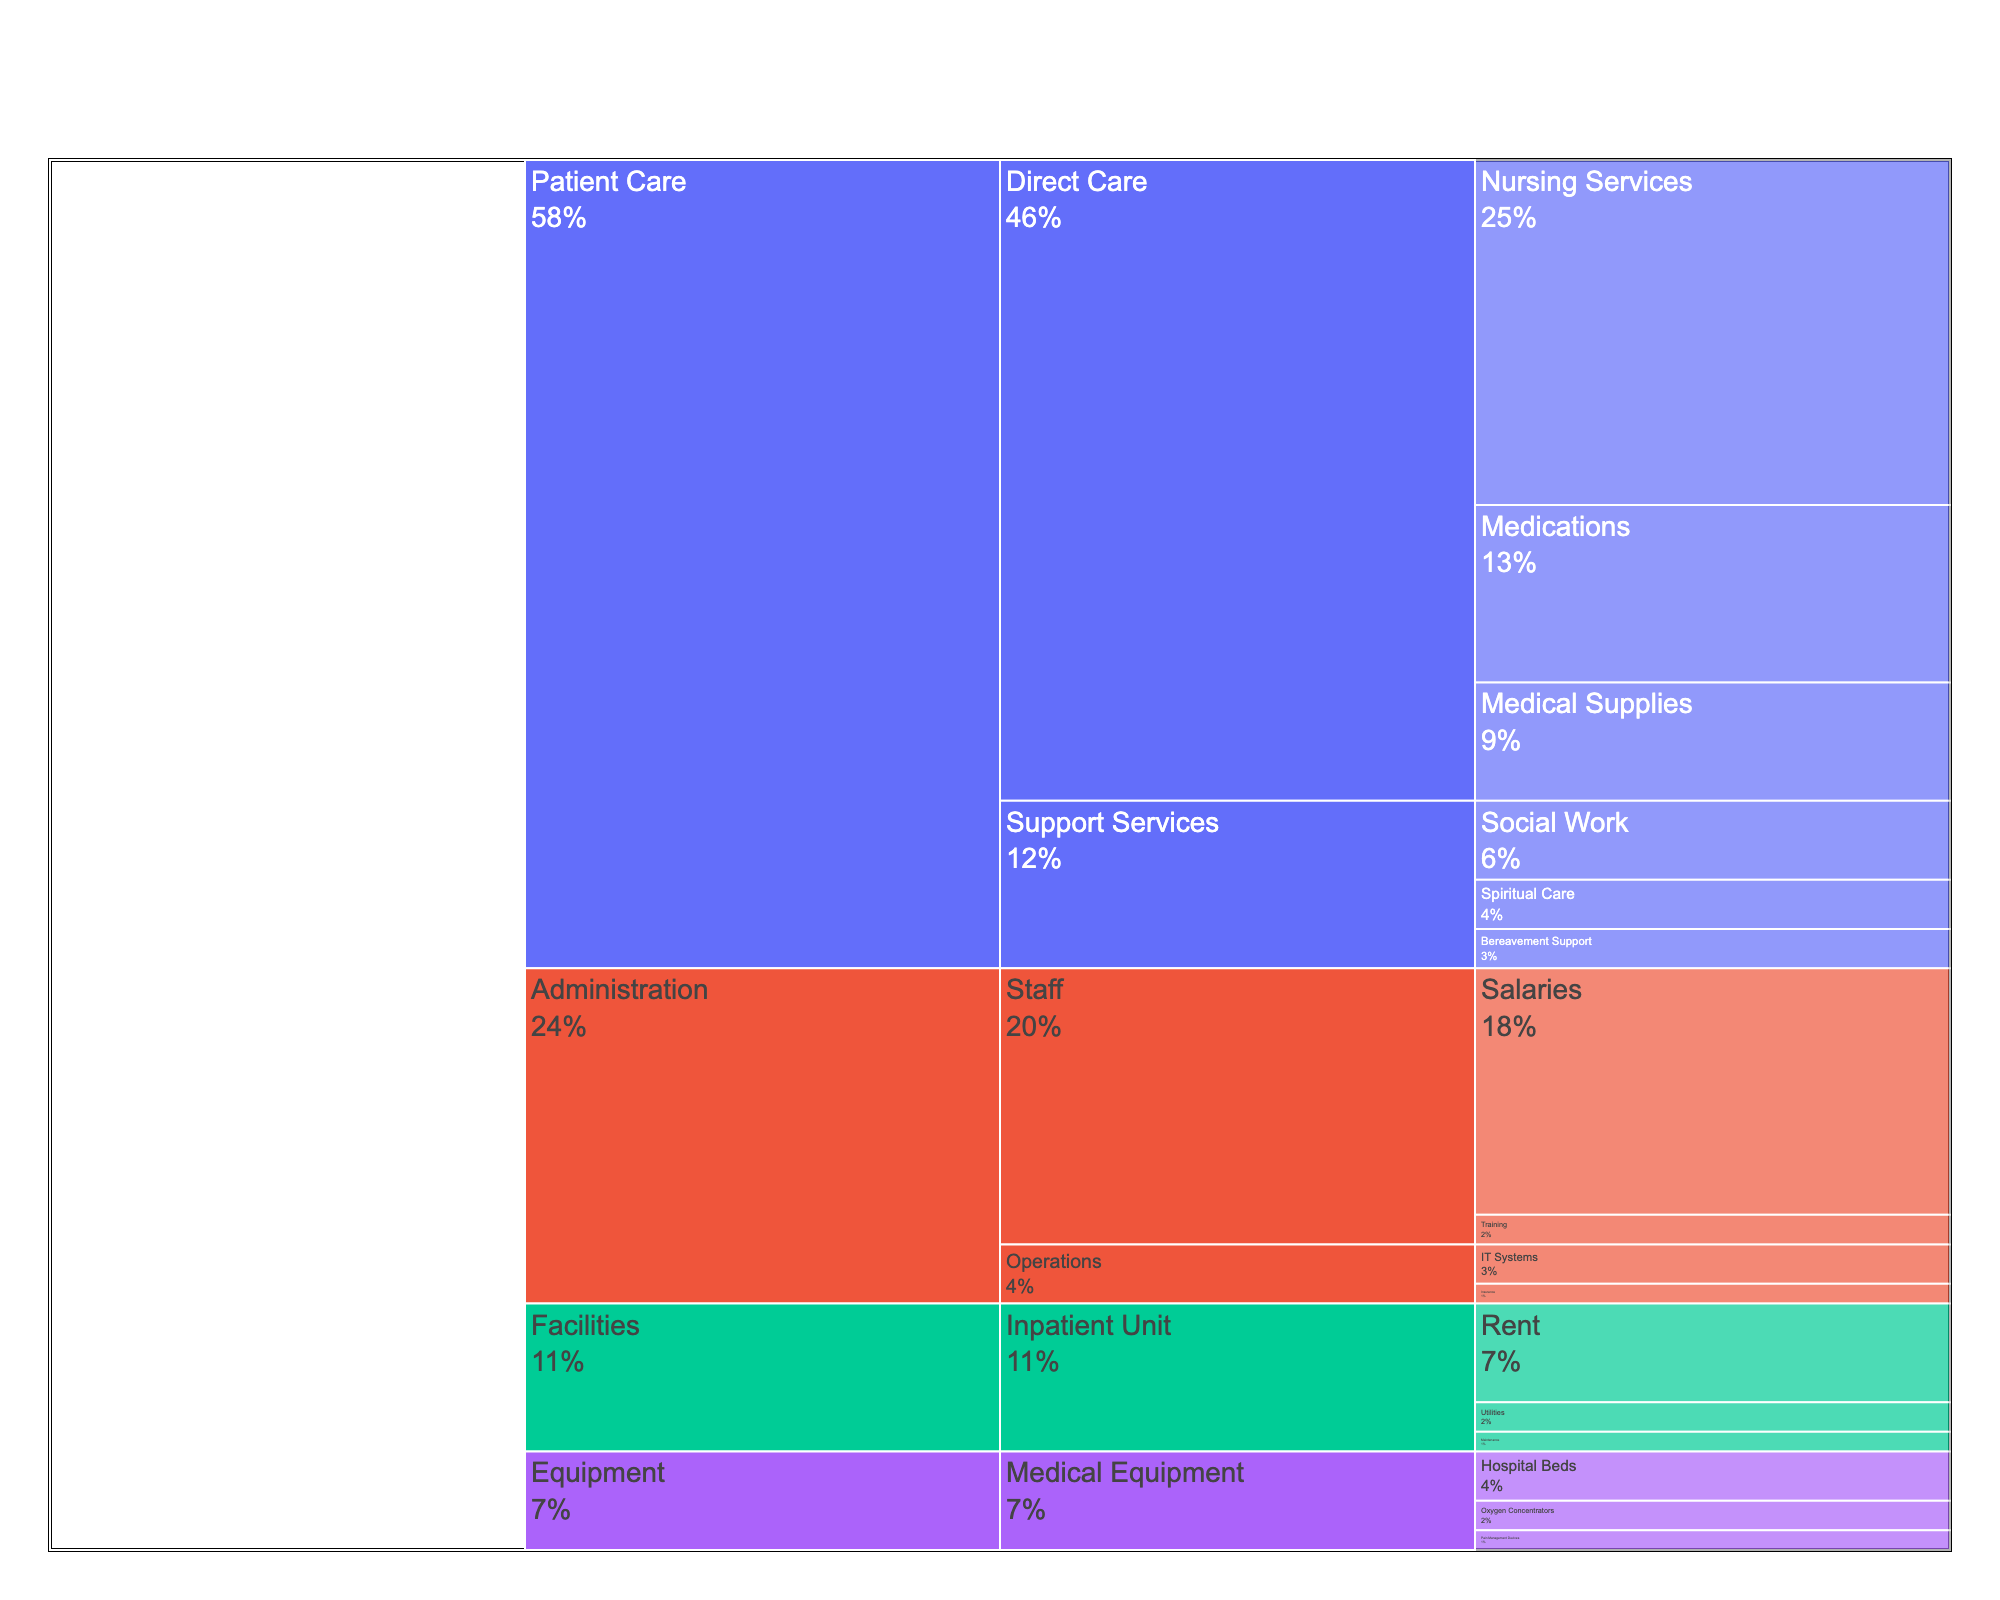What is the total budget allocated to Patient Care? Sum up all the values within the Patient Care category: 35 (Nursing Services) + 12 (Medical Supplies) + 18 (Medications) + 8 (Social Work) + 5 (Spiritual Care) + 4 (Bereavement Support) = 82
Answer: 82 What percentage of the total budget is allocated to Nursing Services? Divide the budget for Nursing Services by the total budget and multiply by 100: (35 / (35 + 12 + 18 + 8 + 5 + 4 + 10 + 3 + 2 + 5 + 3 + 2 + 25 + 3 + 4 + 2)) * 100 ≈ (35 / 141) * 100 ≈ 24.8%
Answer: 24.8% How does the budget allocation for Salaries compare to Medical Supplies? Salaries have a budget of 25, while Medical Supplies have a budget of 12. Therefore, Salaries have a higher allocation (25) compared to Medical Supplies (12).
Answer: Salaries have a higher budget What is the combined budget for Medical Equipment (Hospital Beds, Oxygen Concentrators, and Pain Management Devices)? Sum the budgets for Hospital Beds, Oxygen Concentrators, and Pain Management Devices: 5 + 3 + 2 = 10
Answer: 10 Which subcategory within Patient Care has the lowest allocation, Support Services or Direct Care? Sum up the values within each subcategory: Direct Care = 35 + 12 + 18 = 65, Support Services = 8 + 5 + 4 = 17. Therefore, Support Services has the lower allocation.
Answer: Support Services What is the budget allocation for the Inpatient Unit subcategory? Sum up all the values within the Inpatient Unit: 10 (Rent) + 3 (Utilities) + 2 (Maintenance) = 15
Answer: 15 Is more budget allocated to Social Work or Spiritual Care? Social Work has a budget of 8, whereas Spiritual Care has a budget of 5. Social Work has a higher allocation.
Answer: Social Work Compare the budgets for IT Systems and Training. Which one is higher? IT Systems have a budget of 4, while Training has a budget of 3. IT Systems have a higher budget.
Answer: IT Systems What is the total allocation for the Administration category? Sum up all the values within the Administration category: 25 (Salaries) + 3 (Training) + 4 (IT Systems) + 2 (Insurance) = 34
Answer: 34 Compare the total budget for Direct Care in Patient Care and Inpatient Unit in Facilities. Which one is higher? Direct Care (Patient Care) has a total budget of 65, whereas Inpatient Unit (Facilities) has a total budget of 15. Direct Care has a higher budget.
Answer: Direct Care 